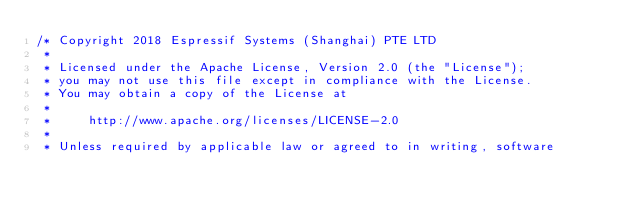<code> <loc_0><loc_0><loc_500><loc_500><_C_>/* Copyright 2018 Espressif Systems (Shanghai) PTE LTD
 *
 * Licensed under the Apache License, Version 2.0 (the "License");
 * you may not use this file except in compliance with the License.
 * You may obtain a copy of the License at
 *
 *     http://www.apache.org/licenses/LICENSE-2.0
 *
 * Unless required by applicable law or agreed to in writing, software</code> 